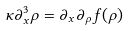<formula> <loc_0><loc_0><loc_500><loc_500>\kappa \partial _ { x } ^ { 3 } \rho = \partial _ { x } \partial _ { \rho } f ( \rho )</formula> 